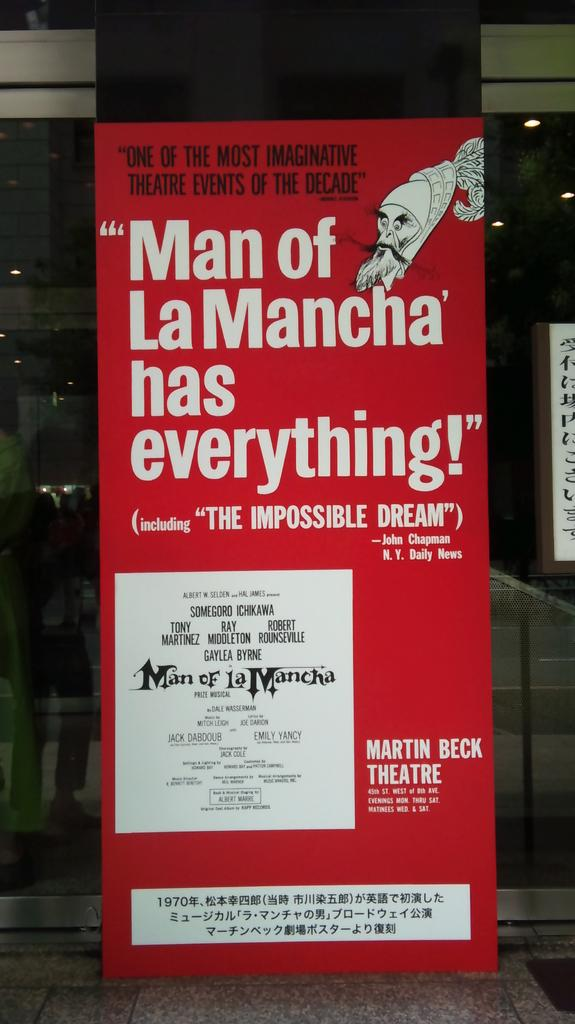Provide a one-sentence caption for the provided image. A theater poster for the Martin Beck Theater and their production of "Man of LaMancha". 